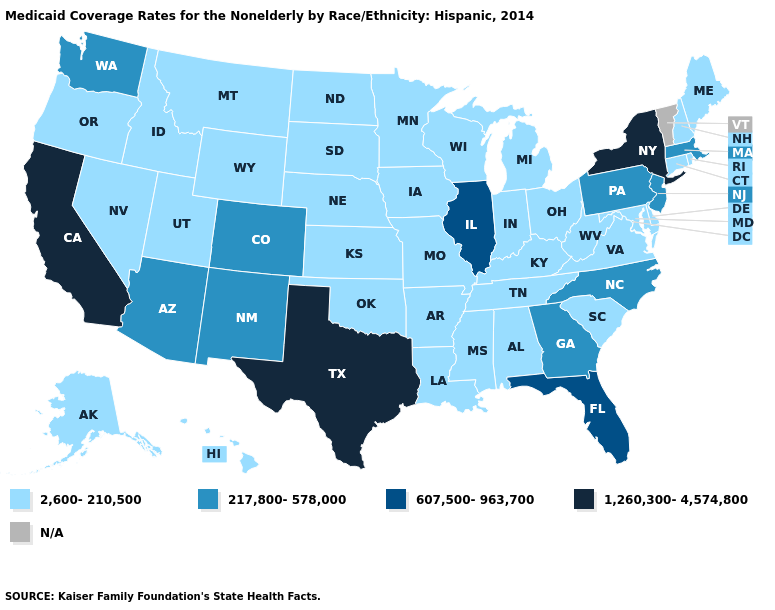What is the value of Colorado?
Give a very brief answer. 217,800-578,000. Name the states that have a value in the range 217,800-578,000?
Quick response, please. Arizona, Colorado, Georgia, Massachusetts, New Jersey, New Mexico, North Carolina, Pennsylvania, Washington. Name the states that have a value in the range 1,260,300-4,574,800?
Short answer required. California, New York, Texas. How many symbols are there in the legend?
Be succinct. 5. What is the value of Delaware?
Write a very short answer. 2,600-210,500. What is the highest value in states that border Minnesota?
Quick response, please. 2,600-210,500. Name the states that have a value in the range 607,500-963,700?
Concise answer only. Florida, Illinois. Is the legend a continuous bar?
Short answer required. No. Does Minnesota have the lowest value in the MidWest?
Write a very short answer. Yes. Name the states that have a value in the range 607,500-963,700?
Write a very short answer. Florida, Illinois. Name the states that have a value in the range 1,260,300-4,574,800?
Write a very short answer. California, New York, Texas. Name the states that have a value in the range 217,800-578,000?
Concise answer only. Arizona, Colorado, Georgia, Massachusetts, New Jersey, New Mexico, North Carolina, Pennsylvania, Washington. Does Texas have the lowest value in the South?
Short answer required. No. What is the highest value in the South ?
Give a very brief answer. 1,260,300-4,574,800. What is the value of New Hampshire?
Keep it brief. 2,600-210,500. 